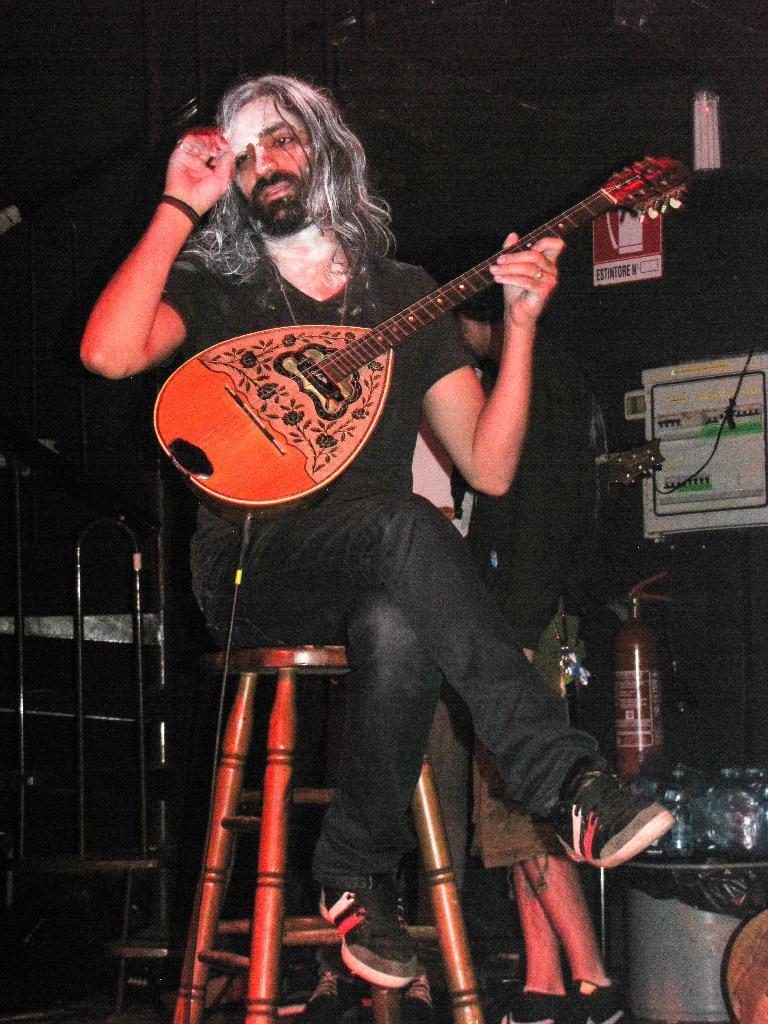In one or two sentences, can you explain what this image depicts? In this image there is a person wearing black color dress sitting on the table and playing guitar. 